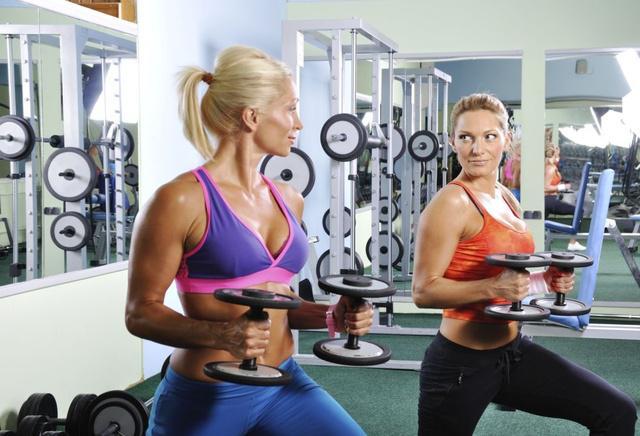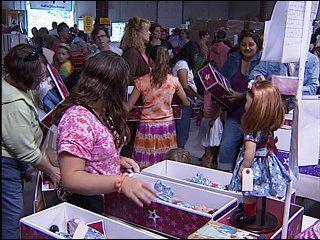The first image is the image on the left, the second image is the image on the right. For the images displayed, is the sentence "The left and right image contains the same number of women." factually correct? Answer yes or no. No. 